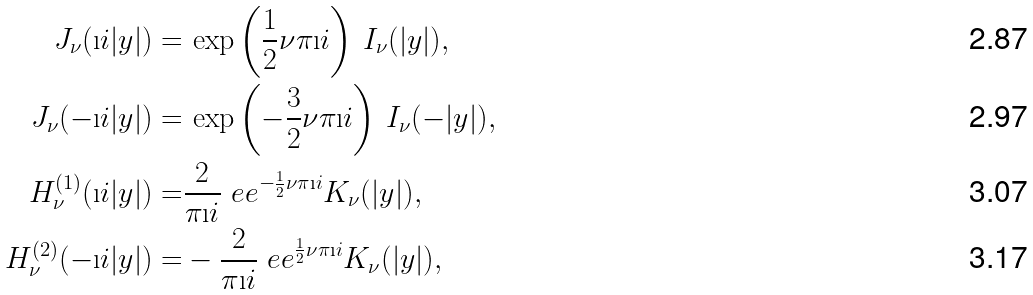Convert formula to latex. <formula><loc_0><loc_0><loc_500><loc_500>J _ { \nu } ( \i i | y | ) = & \, \exp \left ( \frac { 1 } { 2 } \nu \pi \i i \right ) \, I _ { \nu } ( | y | ) , \\ J _ { \nu } ( - \i i | y | ) = & \, \exp \left ( - \frac { 3 } { 2 } \nu \pi \i i \right ) \, I _ { \nu } ( - | y | ) , \\ H _ { \nu } ^ { ( 1 ) } ( \i i | y | ) = & \frac { 2 } { \pi \i i } \ e e ^ { - \frac { 1 } { 2 } \nu \pi \i i } K _ { \nu } ( | y | ) , \\ H _ { \nu } ^ { ( 2 ) } ( - \i i | y | ) = & - \frac { 2 } { \pi \i i } \ e e ^ { \frac { 1 } { 2 } \nu \pi \i i } K _ { \nu } ( | y | ) ,</formula> 